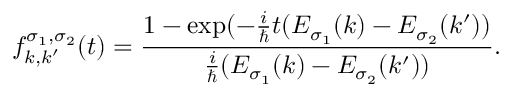Convert formula to latex. <formula><loc_0><loc_0><loc_500><loc_500>f _ { k , k ^ { \prime } } ^ { \sigma _ { 1 } , \sigma _ { 2 } } ( t ) = \frac { 1 - \exp ( - \frac { i } { } t ( E _ { \sigma _ { 1 } } ( k ) - E _ { \sigma _ { 2 } } ( k ^ { \prime } ) ) } { \frac { i } { } ( E _ { \sigma _ { 1 } } ( k ) - E _ { \sigma _ { 2 } } ( k ^ { \prime } ) ) } .</formula> 